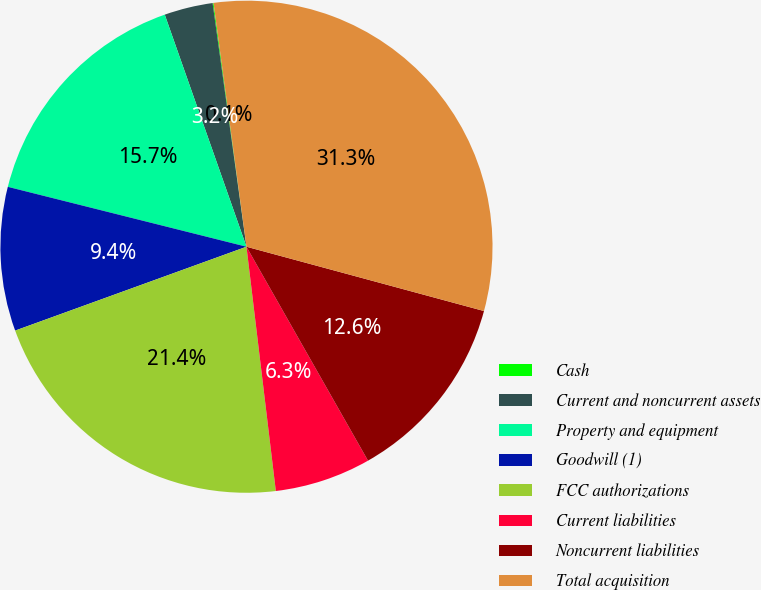Convert chart to OTSL. <chart><loc_0><loc_0><loc_500><loc_500><pie_chart><fcel>Cash<fcel>Current and noncurrent assets<fcel>Property and equipment<fcel>Goodwill (1)<fcel>FCC authorizations<fcel>Current liabilities<fcel>Noncurrent liabilities<fcel>Total acquisition<nl><fcel>0.06%<fcel>3.19%<fcel>15.7%<fcel>9.45%<fcel>21.37%<fcel>6.32%<fcel>12.57%<fcel>31.35%<nl></chart> 